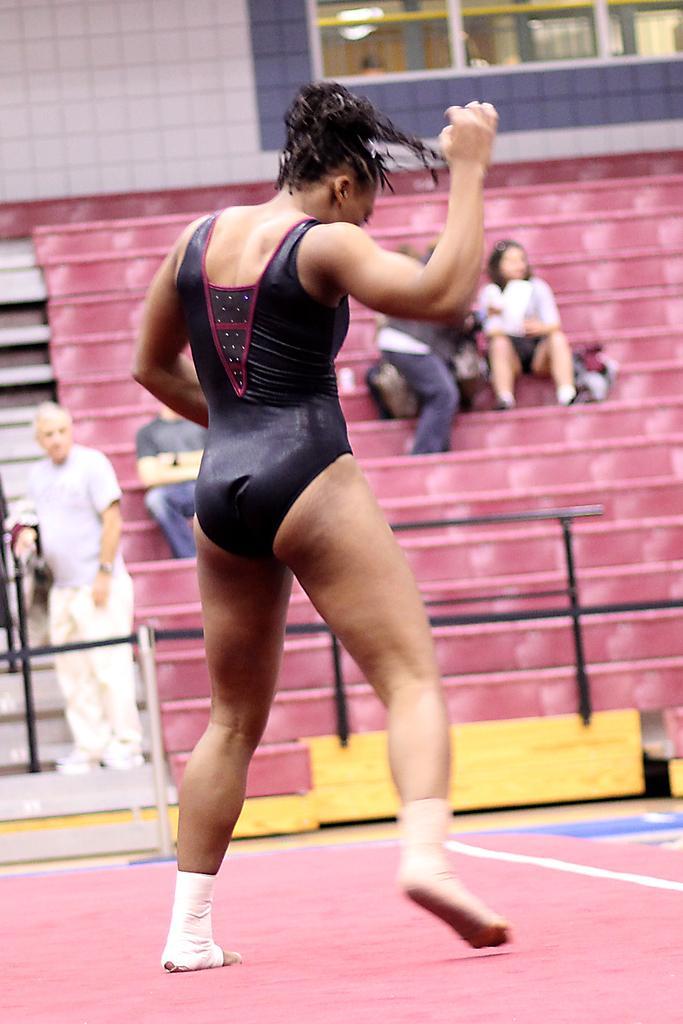How would you summarize this image in a sentence or two? In this image, we can see two persons standing and wearing clothes. There are three persons in the middle of the image sitting on stairs. There is a wall at the top of the image. 